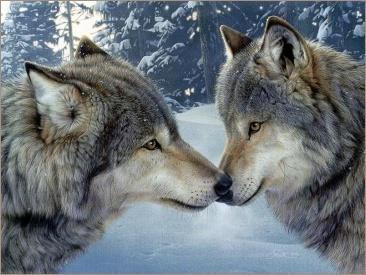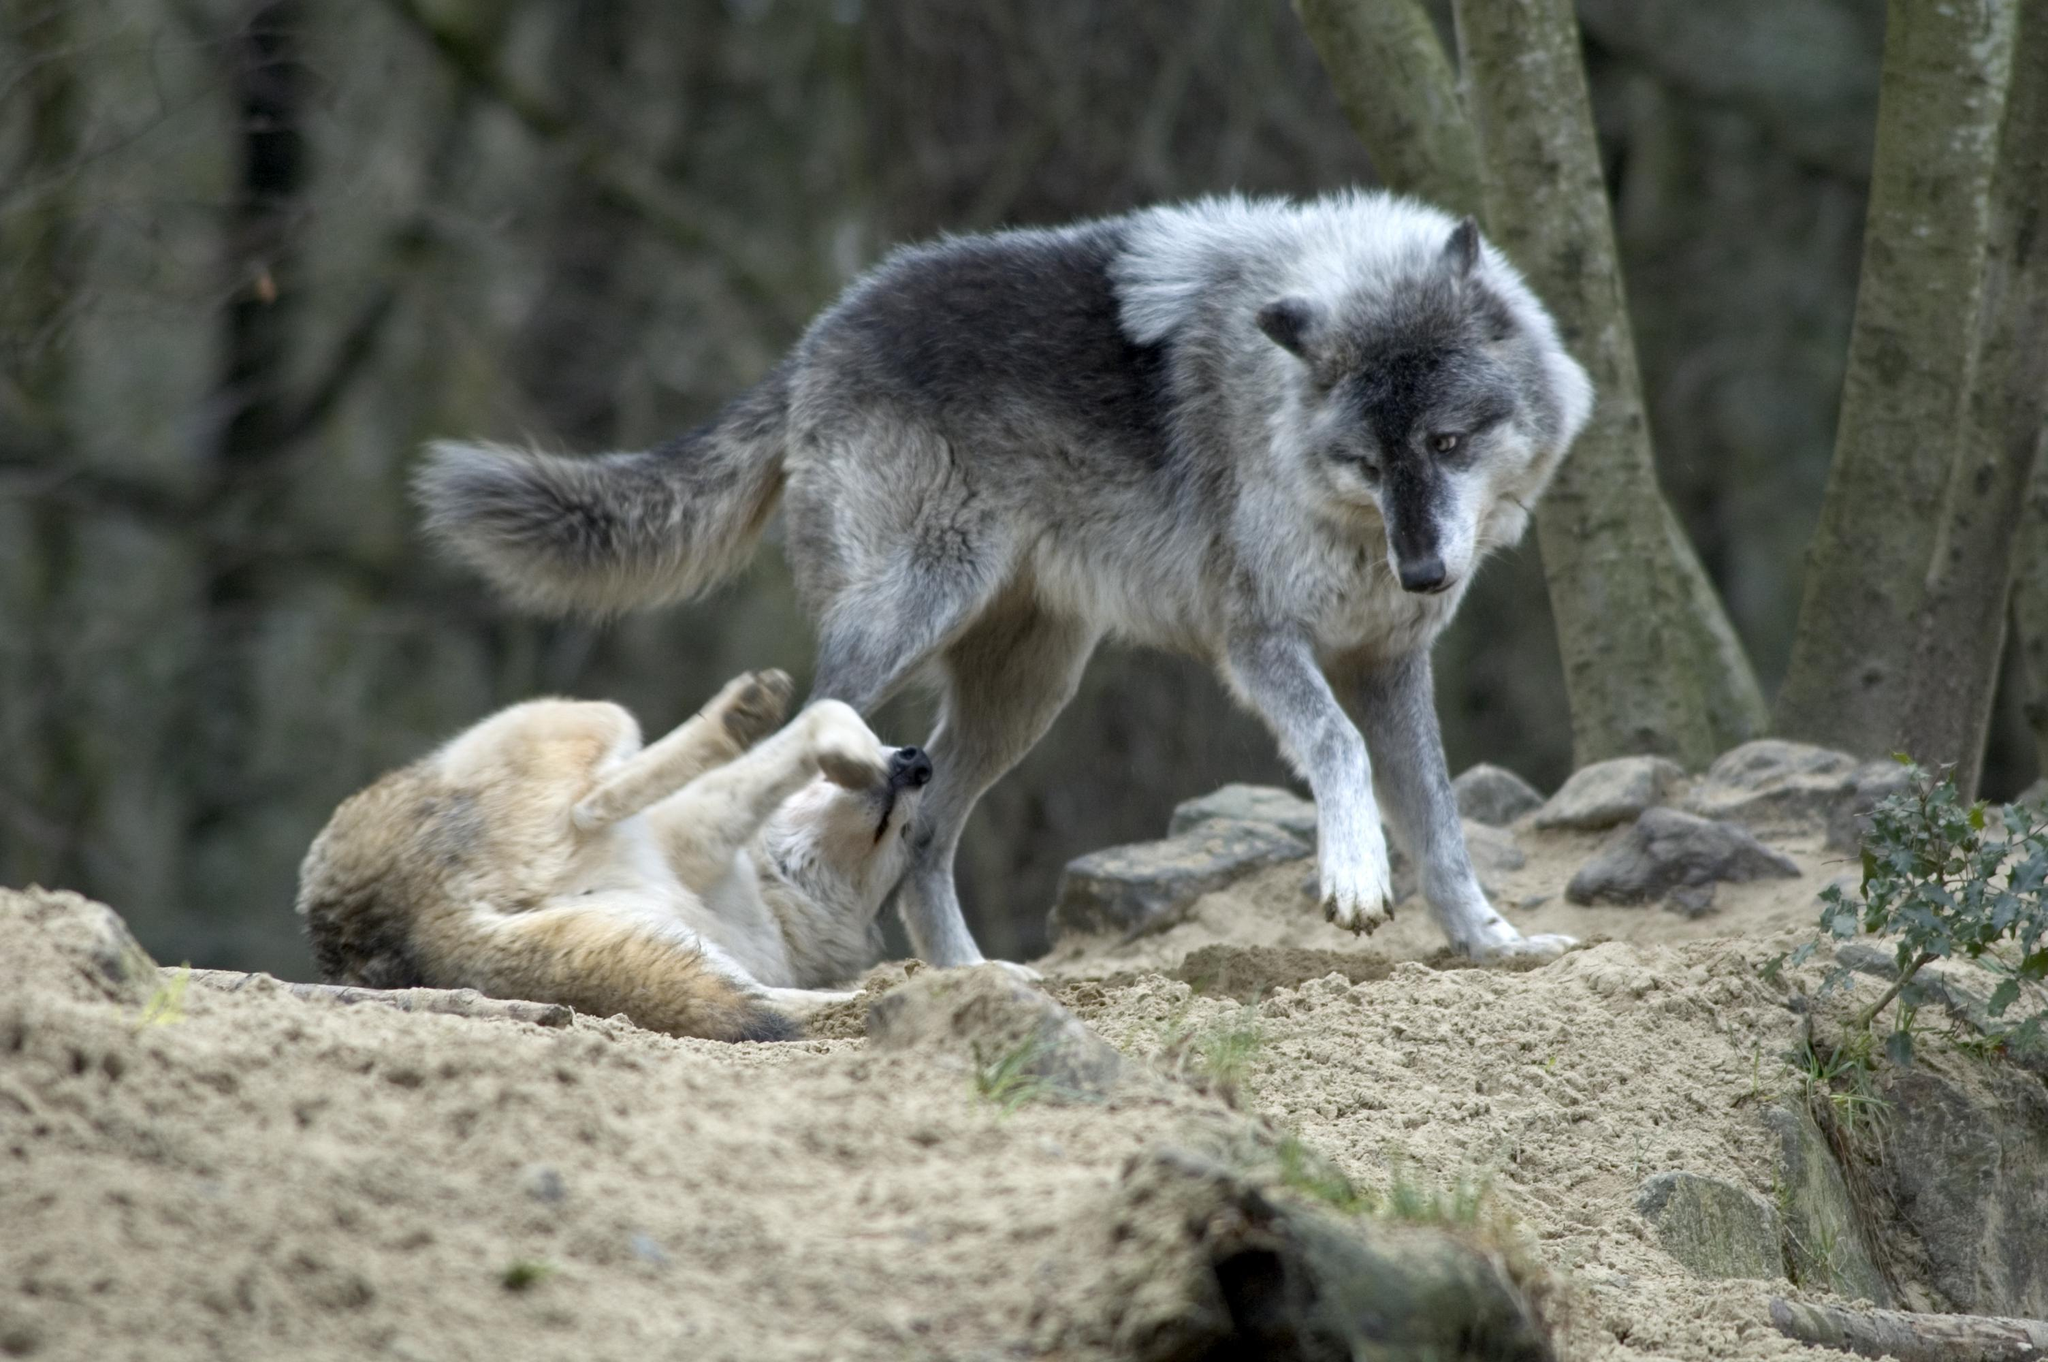The first image is the image on the left, the second image is the image on the right. Examine the images to the left and right. Is the description "The right image shows one wolf standing over another wolf that is lying on its back with its rear to the camera and multiple paws in the air." accurate? Answer yes or no. Yes. The first image is the image on the left, the second image is the image on the right. Given the left and right images, does the statement "At least one of the dogs is lying on the ground." hold true? Answer yes or no. Yes. 